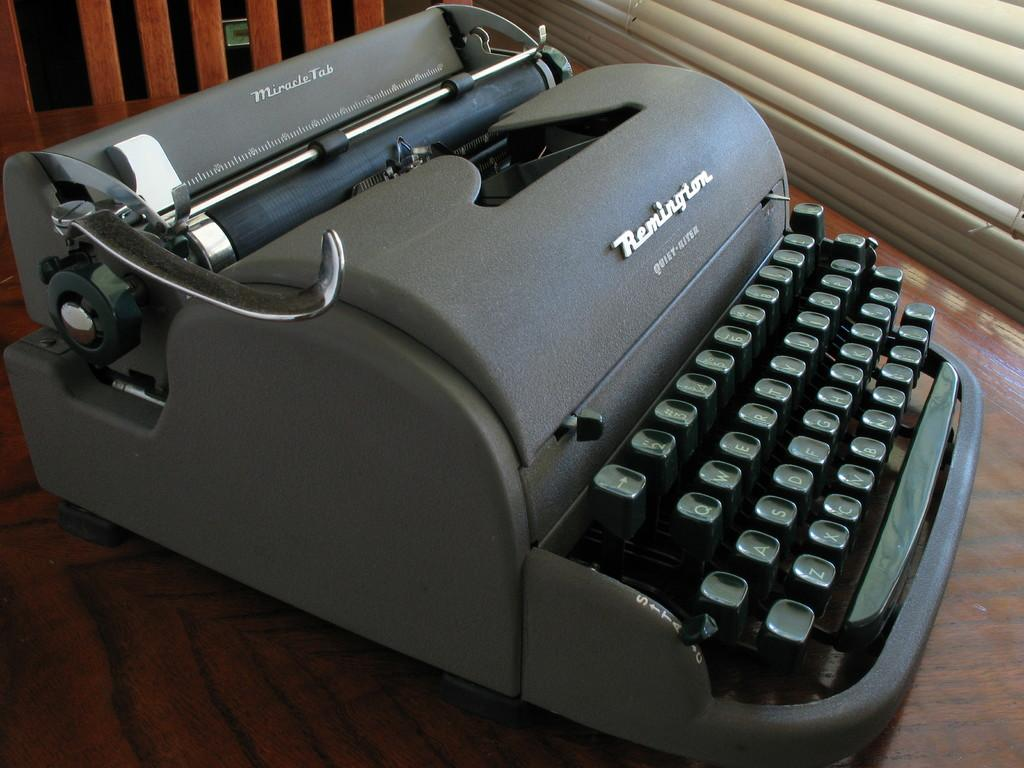<image>
Offer a succinct explanation of the picture presented. Remington type writer of an old fashioned style and raised keys. 